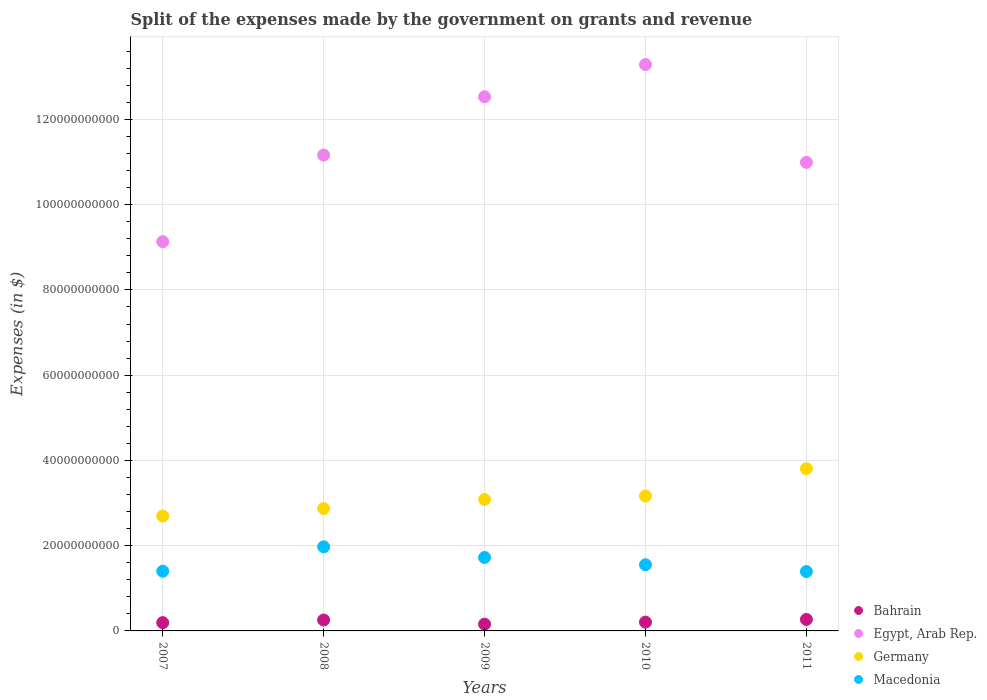How many different coloured dotlines are there?
Keep it short and to the point. 4. What is the expenses made by the government on grants and revenue in Germany in 2010?
Provide a succinct answer. 3.16e+1. Across all years, what is the maximum expenses made by the government on grants and revenue in Egypt, Arab Rep.?
Keep it short and to the point. 1.33e+11. Across all years, what is the minimum expenses made by the government on grants and revenue in Macedonia?
Your answer should be compact. 1.39e+1. In which year was the expenses made by the government on grants and revenue in Egypt, Arab Rep. maximum?
Keep it short and to the point. 2010. In which year was the expenses made by the government on grants and revenue in Germany minimum?
Keep it short and to the point. 2007. What is the total expenses made by the government on grants and revenue in Macedonia in the graph?
Ensure brevity in your answer.  8.04e+1. What is the difference between the expenses made by the government on grants and revenue in Bahrain in 2009 and that in 2010?
Make the answer very short. -4.71e+08. What is the difference between the expenses made by the government on grants and revenue in Bahrain in 2007 and the expenses made by the government on grants and revenue in Egypt, Arab Rep. in 2008?
Provide a succinct answer. -1.10e+11. What is the average expenses made by the government on grants and revenue in Egypt, Arab Rep. per year?
Your answer should be compact. 1.14e+11. In the year 2007, what is the difference between the expenses made by the government on grants and revenue in Egypt, Arab Rep. and expenses made by the government on grants and revenue in Germany?
Ensure brevity in your answer.  6.44e+1. In how many years, is the expenses made by the government on grants and revenue in Macedonia greater than 120000000000 $?
Your answer should be very brief. 0. What is the ratio of the expenses made by the government on grants and revenue in Bahrain in 2009 to that in 2010?
Offer a very short reply. 0.77. What is the difference between the highest and the second highest expenses made by the government on grants and revenue in Bahrain?
Keep it short and to the point. 1.40e+08. What is the difference between the highest and the lowest expenses made by the government on grants and revenue in Macedonia?
Provide a succinct answer. 5.80e+09. Is it the case that in every year, the sum of the expenses made by the government on grants and revenue in Bahrain and expenses made by the government on grants and revenue in Macedonia  is greater than the sum of expenses made by the government on grants and revenue in Germany and expenses made by the government on grants and revenue in Egypt, Arab Rep.?
Make the answer very short. No. Does the expenses made by the government on grants and revenue in Macedonia monotonically increase over the years?
Your answer should be very brief. No. Is the expenses made by the government on grants and revenue in Bahrain strictly greater than the expenses made by the government on grants and revenue in Germany over the years?
Make the answer very short. No. Is the expenses made by the government on grants and revenue in Macedonia strictly less than the expenses made by the government on grants and revenue in Bahrain over the years?
Provide a short and direct response. No. How many years are there in the graph?
Your answer should be very brief. 5. What is the difference between two consecutive major ticks on the Y-axis?
Offer a terse response. 2.00e+1. Are the values on the major ticks of Y-axis written in scientific E-notation?
Keep it short and to the point. No. Does the graph contain grids?
Offer a very short reply. Yes. How many legend labels are there?
Keep it short and to the point. 4. What is the title of the graph?
Ensure brevity in your answer.  Split of the expenses made by the government on grants and revenue. Does "St. Martin (French part)" appear as one of the legend labels in the graph?
Offer a terse response. No. What is the label or title of the Y-axis?
Give a very brief answer. Expenses (in $). What is the Expenses (in $) of Bahrain in 2007?
Your answer should be very brief. 1.94e+09. What is the Expenses (in $) of Egypt, Arab Rep. in 2007?
Your response must be concise. 9.13e+1. What is the Expenses (in $) in Germany in 2007?
Give a very brief answer. 2.70e+1. What is the Expenses (in $) of Macedonia in 2007?
Keep it short and to the point. 1.40e+1. What is the Expenses (in $) of Bahrain in 2008?
Give a very brief answer. 2.56e+09. What is the Expenses (in $) of Egypt, Arab Rep. in 2008?
Your response must be concise. 1.12e+11. What is the Expenses (in $) of Germany in 2008?
Provide a succinct answer. 2.87e+1. What is the Expenses (in $) in Macedonia in 2008?
Provide a succinct answer. 1.97e+1. What is the Expenses (in $) of Bahrain in 2009?
Provide a succinct answer. 1.59e+09. What is the Expenses (in $) of Egypt, Arab Rep. in 2009?
Your answer should be very brief. 1.25e+11. What is the Expenses (in $) in Germany in 2009?
Provide a succinct answer. 3.08e+1. What is the Expenses (in $) in Macedonia in 2009?
Keep it short and to the point. 1.72e+1. What is the Expenses (in $) in Bahrain in 2010?
Your answer should be compact. 2.06e+09. What is the Expenses (in $) in Egypt, Arab Rep. in 2010?
Your response must be concise. 1.33e+11. What is the Expenses (in $) of Germany in 2010?
Your answer should be very brief. 3.16e+1. What is the Expenses (in $) in Macedonia in 2010?
Ensure brevity in your answer.  1.55e+1. What is the Expenses (in $) in Bahrain in 2011?
Offer a terse response. 2.70e+09. What is the Expenses (in $) in Egypt, Arab Rep. in 2011?
Offer a terse response. 1.10e+11. What is the Expenses (in $) in Germany in 2011?
Provide a short and direct response. 3.81e+1. What is the Expenses (in $) in Macedonia in 2011?
Ensure brevity in your answer.  1.39e+1. Across all years, what is the maximum Expenses (in $) of Bahrain?
Your answer should be very brief. 2.70e+09. Across all years, what is the maximum Expenses (in $) of Egypt, Arab Rep.?
Offer a very short reply. 1.33e+11. Across all years, what is the maximum Expenses (in $) in Germany?
Give a very brief answer. 3.81e+1. Across all years, what is the maximum Expenses (in $) in Macedonia?
Your answer should be very brief. 1.97e+1. Across all years, what is the minimum Expenses (in $) in Bahrain?
Make the answer very short. 1.59e+09. Across all years, what is the minimum Expenses (in $) in Egypt, Arab Rep.?
Ensure brevity in your answer.  9.13e+1. Across all years, what is the minimum Expenses (in $) of Germany?
Give a very brief answer. 2.70e+1. Across all years, what is the minimum Expenses (in $) in Macedonia?
Offer a terse response. 1.39e+1. What is the total Expenses (in $) in Bahrain in the graph?
Your response must be concise. 1.09e+1. What is the total Expenses (in $) of Egypt, Arab Rep. in the graph?
Your response must be concise. 5.71e+11. What is the total Expenses (in $) in Germany in the graph?
Provide a short and direct response. 1.56e+11. What is the total Expenses (in $) in Macedonia in the graph?
Provide a succinct answer. 8.04e+1. What is the difference between the Expenses (in $) in Bahrain in 2007 and that in 2008?
Offer a terse response. -6.15e+08. What is the difference between the Expenses (in $) of Egypt, Arab Rep. in 2007 and that in 2008?
Offer a terse response. -2.03e+1. What is the difference between the Expenses (in $) in Germany in 2007 and that in 2008?
Offer a very short reply. -1.77e+09. What is the difference between the Expenses (in $) in Macedonia in 2007 and that in 2008?
Provide a short and direct response. -5.72e+09. What is the difference between the Expenses (in $) in Bahrain in 2007 and that in 2009?
Offer a terse response. 3.53e+08. What is the difference between the Expenses (in $) in Egypt, Arab Rep. in 2007 and that in 2009?
Your answer should be compact. -3.40e+1. What is the difference between the Expenses (in $) of Germany in 2007 and that in 2009?
Give a very brief answer. -3.89e+09. What is the difference between the Expenses (in $) in Macedonia in 2007 and that in 2009?
Your answer should be compact. -3.23e+09. What is the difference between the Expenses (in $) in Bahrain in 2007 and that in 2010?
Your response must be concise. -1.19e+08. What is the difference between the Expenses (in $) of Egypt, Arab Rep. in 2007 and that in 2010?
Your answer should be compact. -4.16e+1. What is the difference between the Expenses (in $) in Germany in 2007 and that in 2010?
Your answer should be very brief. -4.69e+09. What is the difference between the Expenses (in $) of Macedonia in 2007 and that in 2010?
Give a very brief answer. -1.52e+09. What is the difference between the Expenses (in $) in Bahrain in 2007 and that in 2011?
Make the answer very short. -7.55e+08. What is the difference between the Expenses (in $) in Egypt, Arab Rep. in 2007 and that in 2011?
Give a very brief answer. -1.86e+1. What is the difference between the Expenses (in $) of Germany in 2007 and that in 2011?
Make the answer very short. -1.11e+1. What is the difference between the Expenses (in $) in Macedonia in 2007 and that in 2011?
Provide a short and direct response. 7.66e+07. What is the difference between the Expenses (in $) in Bahrain in 2008 and that in 2009?
Make the answer very short. 9.68e+08. What is the difference between the Expenses (in $) in Egypt, Arab Rep. in 2008 and that in 2009?
Offer a very short reply. -1.37e+1. What is the difference between the Expenses (in $) in Germany in 2008 and that in 2009?
Your response must be concise. -2.12e+09. What is the difference between the Expenses (in $) of Macedonia in 2008 and that in 2009?
Provide a short and direct response. 2.49e+09. What is the difference between the Expenses (in $) of Bahrain in 2008 and that in 2010?
Give a very brief answer. 4.96e+08. What is the difference between the Expenses (in $) of Egypt, Arab Rep. in 2008 and that in 2010?
Offer a very short reply. -2.12e+1. What is the difference between the Expenses (in $) in Germany in 2008 and that in 2010?
Give a very brief answer. -2.92e+09. What is the difference between the Expenses (in $) of Macedonia in 2008 and that in 2010?
Provide a short and direct response. 4.20e+09. What is the difference between the Expenses (in $) in Bahrain in 2008 and that in 2011?
Your answer should be very brief. -1.40e+08. What is the difference between the Expenses (in $) in Egypt, Arab Rep. in 2008 and that in 2011?
Keep it short and to the point. 1.70e+09. What is the difference between the Expenses (in $) of Germany in 2008 and that in 2011?
Ensure brevity in your answer.  -9.34e+09. What is the difference between the Expenses (in $) in Macedonia in 2008 and that in 2011?
Provide a succinct answer. 5.80e+09. What is the difference between the Expenses (in $) of Bahrain in 2009 and that in 2010?
Offer a terse response. -4.71e+08. What is the difference between the Expenses (in $) of Egypt, Arab Rep. in 2009 and that in 2010?
Give a very brief answer. -7.56e+09. What is the difference between the Expenses (in $) in Germany in 2009 and that in 2010?
Give a very brief answer. -8.00e+08. What is the difference between the Expenses (in $) in Macedonia in 2009 and that in 2010?
Your response must be concise. 1.71e+09. What is the difference between the Expenses (in $) in Bahrain in 2009 and that in 2011?
Your response must be concise. -1.11e+09. What is the difference between the Expenses (in $) of Egypt, Arab Rep. in 2009 and that in 2011?
Keep it short and to the point. 1.54e+1. What is the difference between the Expenses (in $) of Germany in 2009 and that in 2011?
Keep it short and to the point. -7.22e+09. What is the difference between the Expenses (in $) in Macedonia in 2009 and that in 2011?
Your response must be concise. 3.30e+09. What is the difference between the Expenses (in $) in Bahrain in 2010 and that in 2011?
Offer a terse response. -6.37e+08. What is the difference between the Expenses (in $) of Egypt, Arab Rep. in 2010 and that in 2011?
Ensure brevity in your answer.  2.29e+1. What is the difference between the Expenses (in $) in Germany in 2010 and that in 2011?
Ensure brevity in your answer.  -6.42e+09. What is the difference between the Expenses (in $) in Macedonia in 2010 and that in 2011?
Your response must be concise. 1.59e+09. What is the difference between the Expenses (in $) of Bahrain in 2007 and the Expenses (in $) of Egypt, Arab Rep. in 2008?
Provide a succinct answer. -1.10e+11. What is the difference between the Expenses (in $) of Bahrain in 2007 and the Expenses (in $) of Germany in 2008?
Your answer should be very brief. -2.68e+1. What is the difference between the Expenses (in $) of Bahrain in 2007 and the Expenses (in $) of Macedonia in 2008?
Provide a succinct answer. -1.78e+1. What is the difference between the Expenses (in $) of Egypt, Arab Rep. in 2007 and the Expenses (in $) of Germany in 2008?
Make the answer very short. 6.26e+1. What is the difference between the Expenses (in $) in Egypt, Arab Rep. in 2007 and the Expenses (in $) in Macedonia in 2008?
Keep it short and to the point. 7.16e+1. What is the difference between the Expenses (in $) of Germany in 2007 and the Expenses (in $) of Macedonia in 2008?
Offer a very short reply. 7.22e+09. What is the difference between the Expenses (in $) of Bahrain in 2007 and the Expenses (in $) of Egypt, Arab Rep. in 2009?
Keep it short and to the point. -1.23e+11. What is the difference between the Expenses (in $) of Bahrain in 2007 and the Expenses (in $) of Germany in 2009?
Your answer should be very brief. -2.89e+1. What is the difference between the Expenses (in $) of Bahrain in 2007 and the Expenses (in $) of Macedonia in 2009?
Your answer should be very brief. -1.53e+1. What is the difference between the Expenses (in $) of Egypt, Arab Rep. in 2007 and the Expenses (in $) of Germany in 2009?
Offer a terse response. 6.05e+1. What is the difference between the Expenses (in $) in Egypt, Arab Rep. in 2007 and the Expenses (in $) in Macedonia in 2009?
Provide a succinct answer. 7.41e+1. What is the difference between the Expenses (in $) in Germany in 2007 and the Expenses (in $) in Macedonia in 2009?
Provide a short and direct response. 9.72e+09. What is the difference between the Expenses (in $) of Bahrain in 2007 and the Expenses (in $) of Egypt, Arab Rep. in 2010?
Keep it short and to the point. -1.31e+11. What is the difference between the Expenses (in $) of Bahrain in 2007 and the Expenses (in $) of Germany in 2010?
Your answer should be compact. -2.97e+1. What is the difference between the Expenses (in $) in Bahrain in 2007 and the Expenses (in $) in Macedonia in 2010?
Make the answer very short. -1.36e+1. What is the difference between the Expenses (in $) of Egypt, Arab Rep. in 2007 and the Expenses (in $) of Germany in 2010?
Provide a succinct answer. 5.97e+1. What is the difference between the Expenses (in $) in Egypt, Arab Rep. in 2007 and the Expenses (in $) in Macedonia in 2010?
Provide a short and direct response. 7.58e+1. What is the difference between the Expenses (in $) in Germany in 2007 and the Expenses (in $) in Macedonia in 2010?
Provide a short and direct response. 1.14e+1. What is the difference between the Expenses (in $) in Bahrain in 2007 and the Expenses (in $) in Egypt, Arab Rep. in 2011?
Ensure brevity in your answer.  -1.08e+11. What is the difference between the Expenses (in $) of Bahrain in 2007 and the Expenses (in $) of Germany in 2011?
Provide a short and direct response. -3.61e+1. What is the difference between the Expenses (in $) of Bahrain in 2007 and the Expenses (in $) of Macedonia in 2011?
Your response must be concise. -1.20e+1. What is the difference between the Expenses (in $) of Egypt, Arab Rep. in 2007 and the Expenses (in $) of Germany in 2011?
Ensure brevity in your answer.  5.33e+1. What is the difference between the Expenses (in $) in Egypt, Arab Rep. in 2007 and the Expenses (in $) in Macedonia in 2011?
Offer a very short reply. 7.74e+1. What is the difference between the Expenses (in $) in Germany in 2007 and the Expenses (in $) in Macedonia in 2011?
Your answer should be compact. 1.30e+1. What is the difference between the Expenses (in $) in Bahrain in 2008 and the Expenses (in $) in Egypt, Arab Rep. in 2009?
Keep it short and to the point. -1.23e+11. What is the difference between the Expenses (in $) in Bahrain in 2008 and the Expenses (in $) in Germany in 2009?
Keep it short and to the point. -2.83e+1. What is the difference between the Expenses (in $) in Bahrain in 2008 and the Expenses (in $) in Macedonia in 2009?
Give a very brief answer. -1.47e+1. What is the difference between the Expenses (in $) in Egypt, Arab Rep. in 2008 and the Expenses (in $) in Germany in 2009?
Give a very brief answer. 8.08e+1. What is the difference between the Expenses (in $) in Egypt, Arab Rep. in 2008 and the Expenses (in $) in Macedonia in 2009?
Ensure brevity in your answer.  9.44e+1. What is the difference between the Expenses (in $) in Germany in 2008 and the Expenses (in $) in Macedonia in 2009?
Make the answer very short. 1.15e+1. What is the difference between the Expenses (in $) of Bahrain in 2008 and the Expenses (in $) of Egypt, Arab Rep. in 2010?
Keep it short and to the point. -1.30e+11. What is the difference between the Expenses (in $) of Bahrain in 2008 and the Expenses (in $) of Germany in 2010?
Your answer should be very brief. -2.91e+1. What is the difference between the Expenses (in $) of Bahrain in 2008 and the Expenses (in $) of Macedonia in 2010?
Make the answer very short. -1.30e+1. What is the difference between the Expenses (in $) of Egypt, Arab Rep. in 2008 and the Expenses (in $) of Germany in 2010?
Provide a succinct answer. 8.00e+1. What is the difference between the Expenses (in $) of Egypt, Arab Rep. in 2008 and the Expenses (in $) of Macedonia in 2010?
Offer a very short reply. 9.61e+1. What is the difference between the Expenses (in $) of Germany in 2008 and the Expenses (in $) of Macedonia in 2010?
Your answer should be compact. 1.32e+1. What is the difference between the Expenses (in $) in Bahrain in 2008 and the Expenses (in $) in Egypt, Arab Rep. in 2011?
Give a very brief answer. -1.07e+11. What is the difference between the Expenses (in $) of Bahrain in 2008 and the Expenses (in $) of Germany in 2011?
Your response must be concise. -3.55e+1. What is the difference between the Expenses (in $) of Bahrain in 2008 and the Expenses (in $) of Macedonia in 2011?
Ensure brevity in your answer.  -1.14e+1. What is the difference between the Expenses (in $) in Egypt, Arab Rep. in 2008 and the Expenses (in $) in Germany in 2011?
Give a very brief answer. 7.36e+1. What is the difference between the Expenses (in $) in Egypt, Arab Rep. in 2008 and the Expenses (in $) in Macedonia in 2011?
Provide a succinct answer. 9.77e+1. What is the difference between the Expenses (in $) in Germany in 2008 and the Expenses (in $) in Macedonia in 2011?
Provide a short and direct response. 1.48e+1. What is the difference between the Expenses (in $) in Bahrain in 2009 and the Expenses (in $) in Egypt, Arab Rep. in 2010?
Provide a succinct answer. -1.31e+11. What is the difference between the Expenses (in $) in Bahrain in 2009 and the Expenses (in $) in Germany in 2010?
Offer a very short reply. -3.00e+1. What is the difference between the Expenses (in $) in Bahrain in 2009 and the Expenses (in $) in Macedonia in 2010?
Your answer should be very brief. -1.39e+1. What is the difference between the Expenses (in $) in Egypt, Arab Rep. in 2009 and the Expenses (in $) in Germany in 2010?
Keep it short and to the point. 9.37e+1. What is the difference between the Expenses (in $) of Egypt, Arab Rep. in 2009 and the Expenses (in $) of Macedonia in 2010?
Your answer should be very brief. 1.10e+11. What is the difference between the Expenses (in $) in Germany in 2009 and the Expenses (in $) in Macedonia in 2010?
Keep it short and to the point. 1.53e+1. What is the difference between the Expenses (in $) of Bahrain in 2009 and the Expenses (in $) of Egypt, Arab Rep. in 2011?
Ensure brevity in your answer.  -1.08e+11. What is the difference between the Expenses (in $) of Bahrain in 2009 and the Expenses (in $) of Germany in 2011?
Make the answer very short. -3.65e+1. What is the difference between the Expenses (in $) of Bahrain in 2009 and the Expenses (in $) of Macedonia in 2011?
Provide a succinct answer. -1.23e+1. What is the difference between the Expenses (in $) in Egypt, Arab Rep. in 2009 and the Expenses (in $) in Germany in 2011?
Offer a very short reply. 8.73e+1. What is the difference between the Expenses (in $) in Egypt, Arab Rep. in 2009 and the Expenses (in $) in Macedonia in 2011?
Ensure brevity in your answer.  1.11e+11. What is the difference between the Expenses (in $) in Germany in 2009 and the Expenses (in $) in Macedonia in 2011?
Give a very brief answer. 1.69e+1. What is the difference between the Expenses (in $) in Bahrain in 2010 and the Expenses (in $) in Egypt, Arab Rep. in 2011?
Offer a terse response. -1.08e+11. What is the difference between the Expenses (in $) in Bahrain in 2010 and the Expenses (in $) in Germany in 2011?
Provide a succinct answer. -3.60e+1. What is the difference between the Expenses (in $) of Bahrain in 2010 and the Expenses (in $) of Macedonia in 2011?
Offer a terse response. -1.19e+1. What is the difference between the Expenses (in $) of Egypt, Arab Rep. in 2010 and the Expenses (in $) of Germany in 2011?
Give a very brief answer. 9.48e+1. What is the difference between the Expenses (in $) in Egypt, Arab Rep. in 2010 and the Expenses (in $) in Macedonia in 2011?
Give a very brief answer. 1.19e+11. What is the difference between the Expenses (in $) in Germany in 2010 and the Expenses (in $) in Macedonia in 2011?
Provide a succinct answer. 1.77e+1. What is the average Expenses (in $) of Bahrain per year?
Ensure brevity in your answer.  2.17e+09. What is the average Expenses (in $) in Egypt, Arab Rep. per year?
Your answer should be compact. 1.14e+11. What is the average Expenses (in $) of Germany per year?
Your answer should be compact. 3.12e+1. What is the average Expenses (in $) in Macedonia per year?
Offer a very short reply. 1.61e+1. In the year 2007, what is the difference between the Expenses (in $) in Bahrain and Expenses (in $) in Egypt, Arab Rep.?
Keep it short and to the point. -8.94e+1. In the year 2007, what is the difference between the Expenses (in $) in Bahrain and Expenses (in $) in Germany?
Your answer should be compact. -2.50e+1. In the year 2007, what is the difference between the Expenses (in $) in Bahrain and Expenses (in $) in Macedonia?
Your response must be concise. -1.21e+1. In the year 2007, what is the difference between the Expenses (in $) in Egypt, Arab Rep. and Expenses (in $) in Germany?
Your response must be concise. 6.44e+1. In the year 2007, what is the difference between the Expenses (in $) of Egypt, Arab Rep. and Expenses (in $) of Macedonia?
Give a very brief answer. 7.73e+1. In the year 2007, what is the difference between the Expenses (in $) of Germany and Expenses (in $) of Macedonia?
Provide a succinct answer. 1.29e+1. In the year 2008, what is the difference between the Expenses (in $) in Bahrain and Expenses (in $) in Egypt, Arab Rep.?
Keep it short and to the point. -1.09e+11. In the year 2008, what is the difference between the Expenses (in $) in Bahrain and Expenses (in $) in Germany?
Your answer should be compact. -2.62e+1. In the year 2008, what is the difference between the Expenses (in $) in Bahrain and Expenses (in $) in Macedonia?
Your answer should be very brief. -1.72e+1. In the year 2008, what is the difference between the Expenses (in $) of Egypt, Arab Rep. and Expenses (in $) of Germany?
Give a very brief answer. 8.29e+1. In the year 2008, what is the difference between the Expenses (in $) in Egypt, Arab Rep. and Expenses (in $) in Macedonia?
Keep it short and to the point. 9.19e+1. In the year 2008, what is the difference between the Expenses (in $) of Germany and Expenses (in $) of Macedonia?
Keep it short and to the point. 8.99e+09. In the year 2009, what is the difference between the Expenses (in $) of Bahrain and Expenses (in $) of Egypt, Arab Rep.?
Give a very brief answer. -1.24e+11. In the year 2009, what is the difference between the Expenses (in $) in Bahrain and Expenses (in $) in Germany?
Provide a succinct answer. -2.92e+1. In the year 2009, what is the difference between the Expenses (in $) of Bahrain and Expenses (in $) of Macedonia?
Make the answer very short. -1.56e+1. In the year 2009, what is the difference between the Expenses (in $) in Egypt, Arab Rep. and Expenses (in $) in Germany?
Make the answer very short. 9.45e+1. In the year 2009, what is the difference between the Expenses (in $) of Egypt, Arab Rep. and Expenses (in $) of Macedonia?
Keep it short and to the point. 1.08e+11. In the year 2009, what is the difference between the Expenses (in $) of Germany and Expenses (in $) of Macedonia?
Your response must be concise. 1.36e+1. In the year 2010, what is the difference between the Expenses (in $) in Bahrain and Expenses (in $) in Egypt, Arab Rep.?
Your response must be concise. -1.31e+11. In the year 2010, what is the difference between the Expenses (in $) in Bahrain and Expenses (in $) in Germany?
Make the answer very short. -2.96e+1. In the year 2010, what is the difference between the Expenses (in $) of Bahrain and Expenses (in $) of Macedonia?
Ensure brevity in your answer.  -1.35e+1. In the year 2010, what is the difference between the Expenses (in $) in Egypt, Arab Rep. and Expenses (in $) in Germany?
Provide a succinct answer. 1.01e+11. In the year 2010, what is the difference between the Expenses (in $) in Egypt, Arab Rep. and Expenses (in $) in Macedonia?
Provide a short and direct response. 1.17e+11. In the year 2010, what is the difference between the Expenses (in $) of Germany and Expenses (in $) of Macedonia?
Give a very brief answer. 1.61e+1. In the year 2011, what is the difference between the Expenses (in $) of Bahrain and Expenses (in $) of Egypt, Arab Rep.?
Ensure brevity in your answer.  -1.07e+11. In the year 2011, what is the difference between the Expenses (in $) of Bahrain and Expenses (in $) of Germany?
Keep it short and to the point. -3.54e+1. In the year 2011, what is the difference between the Expenses (in $) in Bahrain and Expenses (in $) in Macedonia?
Provide a short and direct response. -1.12e+1. In the year 2011, what is the difference between the Expenses (in $) in Egypt, Arab Rep. and Expenses (in $) in Germany?
Provide a succinct answer. 7.19e+1. In the year 2011, what is the difference between the Expenses (in $) in Egypt, Arab Rep. and Expenses (in $) in Macedonia?
Your response must be concise. 9.60e+1. In the year 2011, what is the difference between the Expenses (in $) in Germany and Expenses (in $) in Macedonia?
Your answer should be compact. 2.41e+1. What is the ratio of the Expenses (in $) of Bahrain in 2007 to that in 2008?
Your response must be concise. 0.76. What is the ratio of the Expenses (in $) in Egypt, Arab Rep. in 2007 to that in 2008?
Offer a terse response. 0.82. What is the ratio of the Expenses (in $) of Germany in 2007 to that in 2008?
Your response must be concise. 0.94. What is the ratio of the Expenses (in $) of Macedonia in 2007 to that in 2008?
Make the answer very short. 0.71. What is the ratio of the Expenses (in $) of Bahrain in 2007 to that in 2009?
Provide a succinct answer. 1.22. What is the ratio of the Expenses (in $) of Egypt, Arab Rep. in 2007 to that in 2009?
Ensure brevity in your answer.  0.73. What is the ratio of the Expenses (in $) of Germany in 2007 to that in 2009?
Offer a terse response. 0.87. What is the ratio of the Expenses (in $) of Macedonia in 2007 to that in 2009?
Ensure brevity in your answer.  0.81. What is the ratio of the Expenses (in $) of Bahrain in 2007 to that in 2010?
Your response must be concise. 0.94. What is the ratio of the Expenses (in $) of Egypt, Arab Rep. in 2007 to that in 2010?
Ensure brevity in your answer.  0.69. What is the ratio of the Expenses (in $) in Germany in 2007 to that in 2010?
Your answer should be compact. 0.85. What is the ratio of the Expenses (in $) in Macedonia in 2007 to that in 2010?
Keep it short and to the point. 0.9. What is the ratio of the Expenses (in $) in Bahrain in 2007 to that in 2011?
Your answer should be compact. 0.72. What is the ratio of the Expenses (in $) in Egypt, Arab Rep. in 2007 to that in 2011?
Provide a short and direct response. 0.83. What is the ratio of the Expenses (in $) of Germany in 2007 to that in 2011?
Your response must be concise. 0.71. What is the ratio of the Expenses (in $) in Bahrain in 2008 to that in 2009?
Ensure brevity in your answer.  1.61. What is the ratio of the Expenses (in $) of Egypt, Arab Rep. in 2008 to that in 2009?
Keep it short and to the point. 0.89. What is the ratio of the Expenses (in $) in Germany in 2008 to that in 2009?
Give a very brief answer. 0.93. What is the ratio of the Expenses (in $) in Macedonia in 2008 to that in 2009?
Your answer should be compact. 1.14. What is the ratio of the Expenses (in $) of Bahrain in 2008 to that in 2010?
Offer a terse response. 1.24. What is the ratio of the Expenses (in $) in Egypt, Arab Rep. in 2008 to that in 2010?
Your response must be concise. 0.84. What is the ratio of the Expenses (in $) of Germany in 2008 to that in 2010?
Keep it short and to the point. 0.91. What is the ratio of the Expenses (in $) of Macedonia in 2008 to that in 2010?
Your response must be concise. 1.27. What is the ratio of the Expenses (in $) of Bahrain in 2008 to that in 2011?
Keep it short and to the point. 0.95. What is the ratio of the Expenses (in $) in Egypt, Arab Rep. in 2008 to that in 2011?
Offer a terse response. 1.02. What is the ratio of the Expenses (in $) in Germany in 2008 to that in 2011?
Keep it short and to the point. 0.75. What is the ratio of the Expenses (in $) in Macedonia in 2008 to that in 2011?
Give a very brief answer. 1.42. What is the ratio of the Expenses (in $) in Bahrain in 2009 to that in 2010?
Make the answer very short. 0.77. What is the ratio of the Expenses (in $) of Egypt, Arab Rep. in 2009 to that in 2010?
Ensure brevity in your answer.  0.94. What is the ratio of the Expenses (in $) in Germany in 2009 to that in 2010?
Ensure brevity in your answer.  0.97. What is the ratio of the Expenses (in $) in Macedonia in 2009 to that in 2010?
Keep it short and to the point. 1.11. What is the ratio of the Expenses (in $) of Bahrain in 2009 to that in 2011?
Offer a very short reply. 0.59. What is the ratio of the Expenses (in $) of Egypt, Arab Rep. in 2009 to that in 2011?
Offer a terse response. 1.14. What is the ratio of the Expenses (in $) in Germany in 2009 to that in 2011?
Provide a succinct answer. 0.81. What is the ratio of the Expenses (in $) of Macedonia in 2009 to that in 2011?
Your answer should be compact. 1.24. What is the ratio of the Expenses (in $) in Bahrain in 2010 to that in 2011?
Your answer should be very brief. 0.76. What is the ratio of the Expenses (in $) of Egypt, Arab Rep. in 2010 to that in 2011?
Make the answer very short. 1.21. What is the ratio of the Expenses (in $) of Germany in 2010 to that in 2011?
Keep it short and to the point. 0.83. What is the ratio of the Expenses (in $) of Macedonia in 2010 to that in 2011?
Offer a terse response. 1.11. What is the difference between the highest and the second highest Expenses (in $) in Bahrain?
Make the answer very short. 1.40e+08. What is the difference between the highest and the second highest Expenses (in $) in Egypt, Arab Rep.?
Make the answer very short. 7.56e+09. What is the difference between the highest and the second highest Expenses (in $) in Germany?
Offer a terse response. 6.42e+09. What is the difference between the highest and the second highest Expenses (in $) of Macedonia?
Provide a short and direct response. 2.49e+09. What is the difference between the highest and the lowest Expenses (in $) of Bahrain?
Provide a short and direct response. 1.11e+09. What is the difference between the highest and the lowest Expenses (in $) of Egypt, Arab Rep.?
Offer a terse response. 4.16e+1. What is the difference between the highest and the lowest Expenses (in $) of Germany?
Give a very brief answer. 1.11e+1. What is the difference between the highest and the lowest Expenses (in $) in Macedonia?
Offer a very short reply. 5.80e+09. 